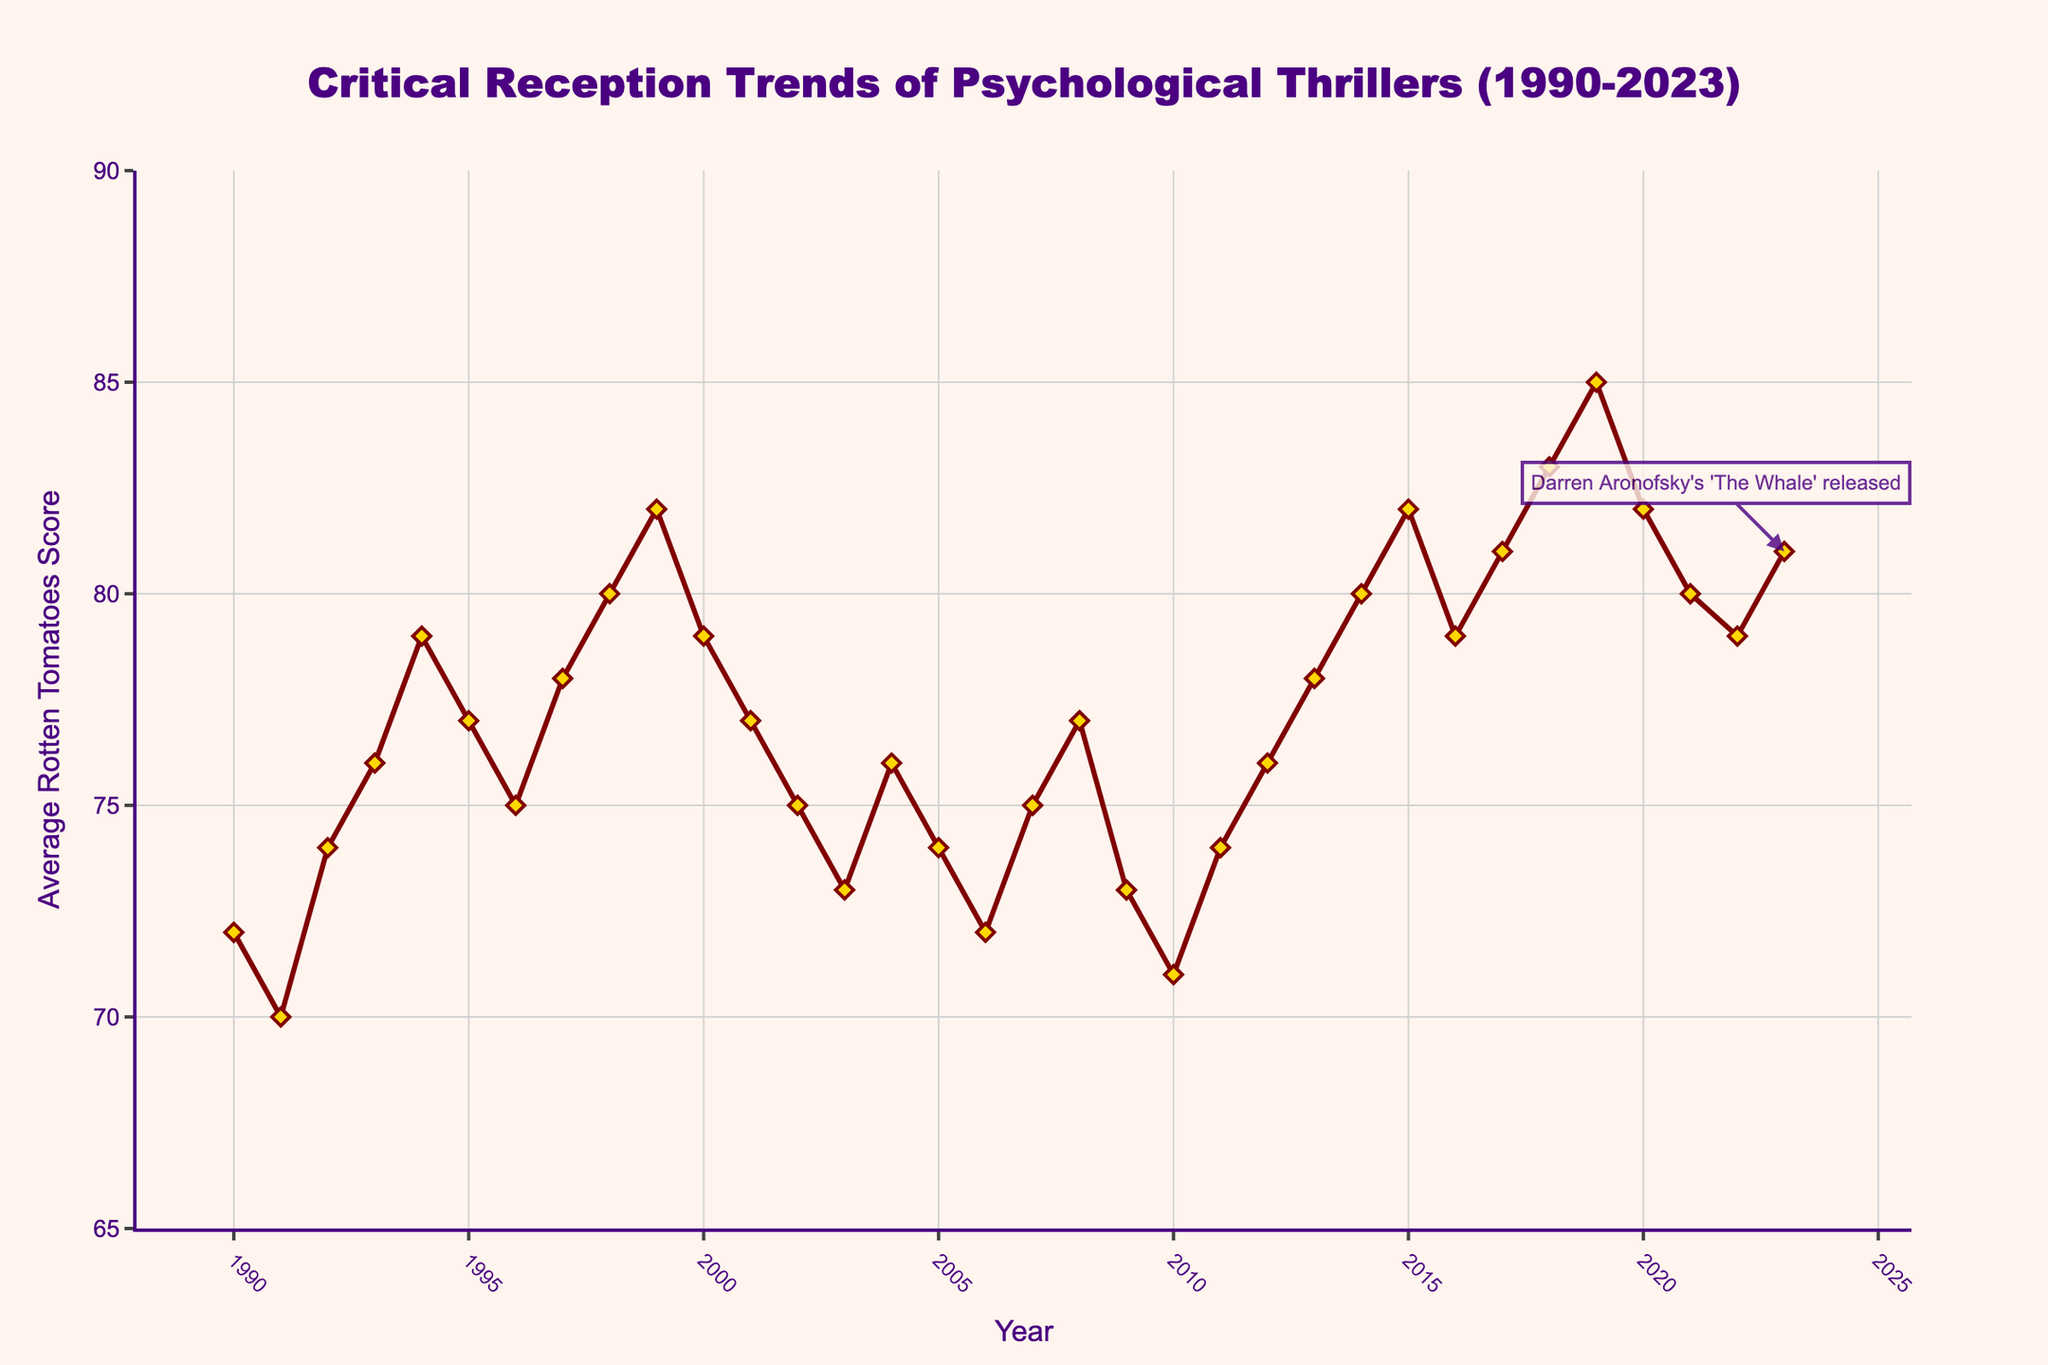what year had the highest average Rotten Tomatoes score for psychological thrillers? Observing the line chart, we see the highest point is in the year 2019, with a score of 85.
Answer: 2019 what was the average Rotten Tomatoes score for psychological thrillers in the year Darren Aronofsky's 'The Whale' was released? According to the annotation in the chart, 'The Whale' was released in 2023, and the score is shown as 81.
Answer: 81 which year had a higher average Rotten Tomatoes score, 2009 or 2010? From the chart, we see that the score in 2009 is 73 and in 2010 is 71, so 2009 had a higher score.
Answer: 2009 calculate the average score for the years with scores above 80 (2018-2020, 2023). The average is calculated as (83+85+82+81) / 4 = 82.75.
Answer: 82.75 did the average Rotten Tomatoes score for psychological thrillers trend up or down from 1990 to 2023? Observing the overall trend of the line, there is an upward trajectory from 1990 to 2023.
Answer: Upward in which contiguous years did psychological thrillers receive the same average Rotten Tomatoes score, according to the chart? From 1996 to 1997, the scores were both 75, the only contiguous period with equal scores.
Answer: 1996-1997 how does the average score in 1999 compare to 2003? The score in 1999 is 82 and in 2003 is 73, thus 1999 has a higher score.
Answer: Higher in 1999 which decade (1990s, 2000s, 2010s) had the most consistent scores? Based on the line chart, the scores in the 1990s showed less fluctuation compared to the 2000s and 2010s, implying more consistency.
Answer: 1990s calculate the difference in average scores between 1990 and 2023. Subtraction of scores for 1990 and 2023 results in 81 - 72 = 9.
Answer: 9 how did the average score change immediately following the year 2012? Examining the chart, the score in 2012 is 76, followed by 78 in 2013, showing an increase.
Answer: Increased 